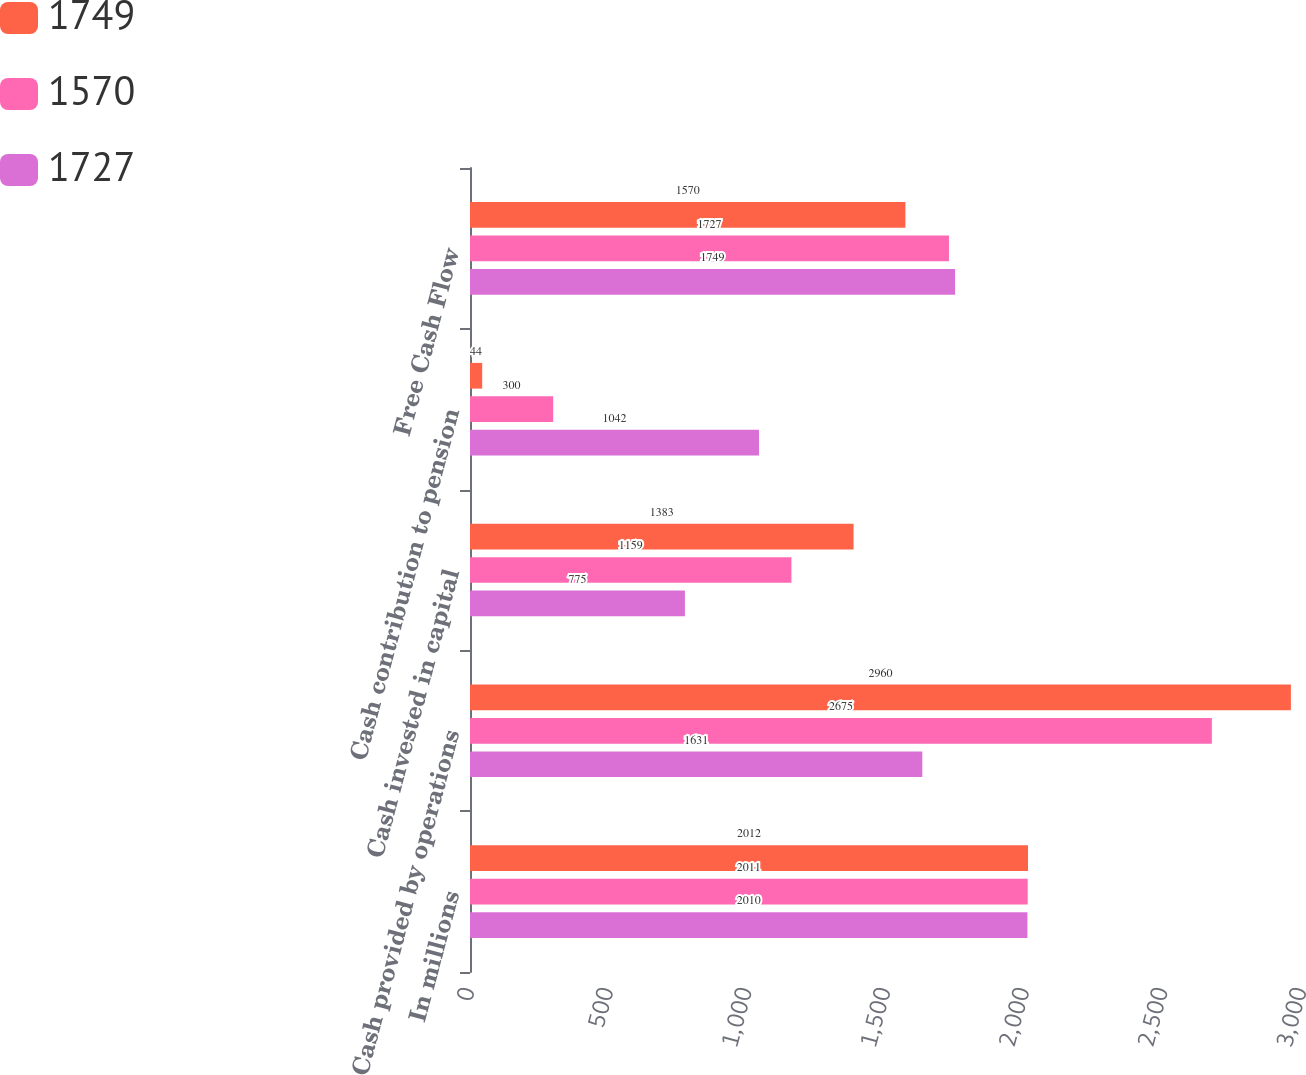<chart> <loc_0><loc_0><loc_500><loc_500><stacked_bar_chart><ecel><fcel>In millions<fcel>Cash provided by operations<fcel>Cash invested in capital<fcel>Cash contribution to pension<fcel>Free Cash Flow<nl><fcel>1749<fcel>2012<fcel>2960<fcel>1383<fcel>44<fcel>1570<nl><fcel>1570<fcel>2011<fcel>2675<fcel>1159<fcel>300<fcel>1727<nl><fcel>1727<fcel>2010<fcel>1631<fcel>775<fcel>1042<fcel>1749<nl></chart> 